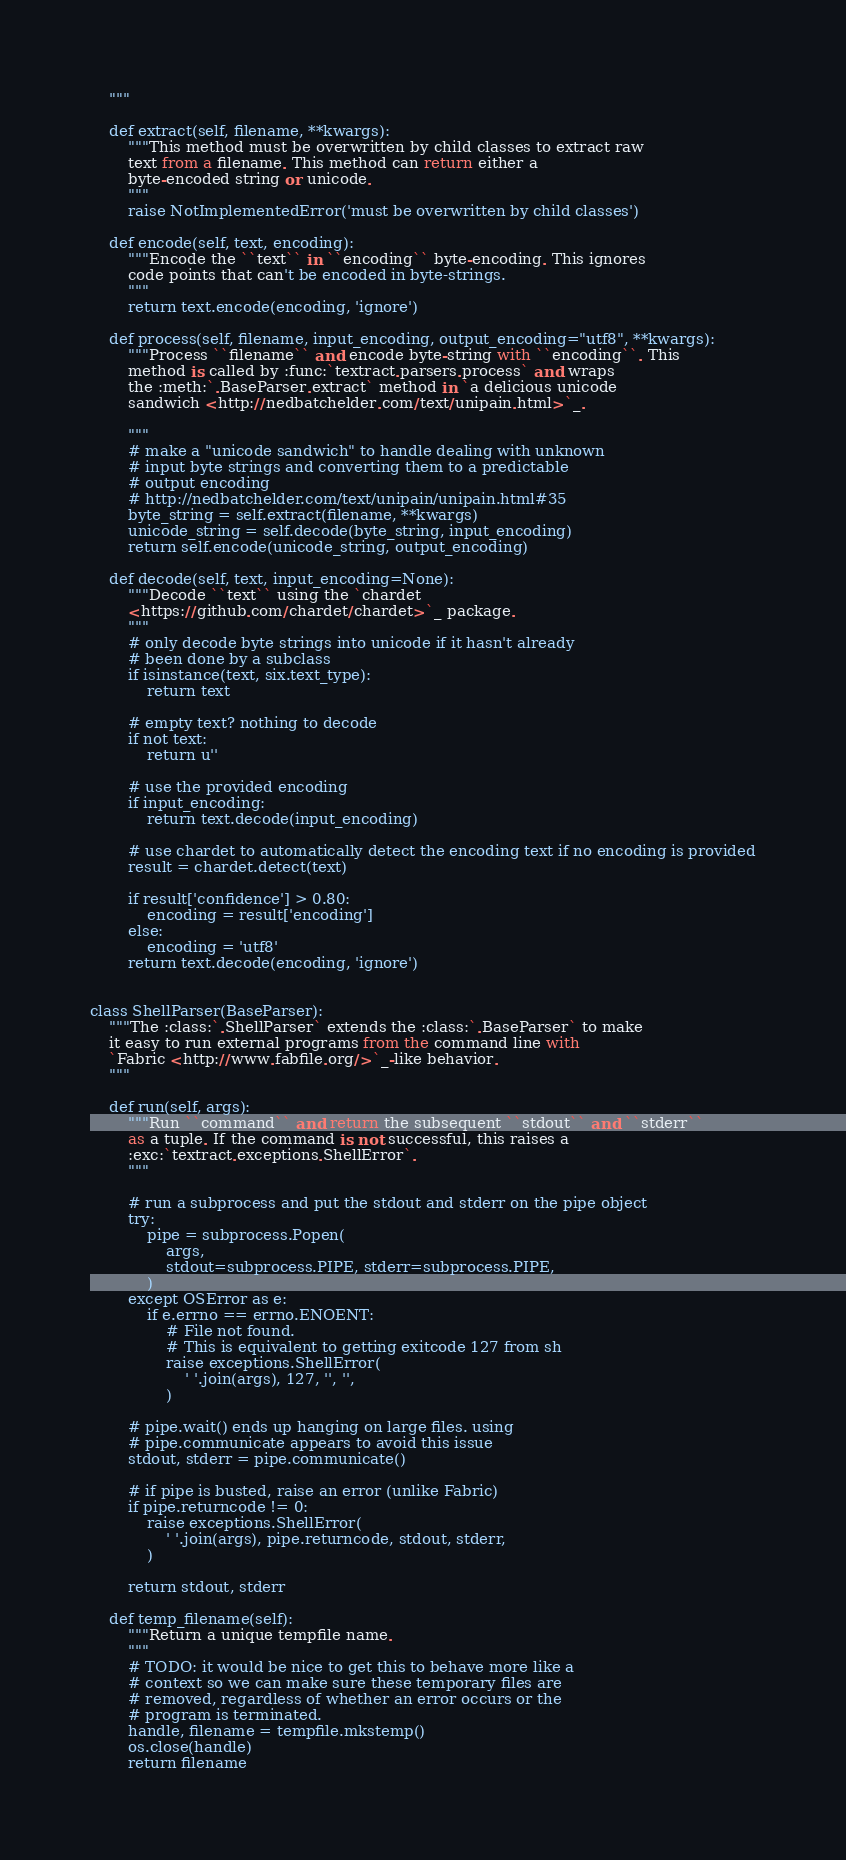Convert code to text. <code><loc_0><loc_0><loc_500><loc_500><_Python_>    """

    def extract(self, filename, **kwargs):
        """This method must be overwritten by child classes to extract raw
        text from a filename. This method can return either a
        byte-encoded string or unicode.
        """
        raise NotImplementedError('must be overwritten by child classes')

    def encode(self, text, encoding):
        """Encode the ``text`` in ``encoding`` byte-encoding. This ignores
        code points that can't be encoded in byte-strings.
        """
        return text.encode(encoding, 'ignore')

    def process(self, filename, input_encoding, output_encoding="utf8", **kwargs):
        """Process ``filename`` and encode byte-string with ``encoding``. This
        method is called by :func:`textract.parsers.process` and wraps
        the :meth:`.BaseParser.extract` method in `a delicious unicode
        sandwich <http://nedbatchelder.com/text/unipain.html>`_.

        """
        # make a "unicode sandwich" to handle dealing with unknown
        # input byte strings and converting them to a predictable
        # output encoding
        # http://nedbatchelder.com/text/unipain/unipain.html#35
        byte_string = self.extract(filename, **kwargs)
        unicode_string = self.decode(byte_string, input_encoding)
        return self.encode(unicode_string, output_encoding)

    def decode(self, text, input_encoding=None):
        """Decode ``text`` using the `chardet
        <https://github.com/chardet/chardet>`_ package.
        """
        # only decode byte strings into unicode if it hasn't already
        # been done by a subclass
        if isinstance(text, six.text_type):
            return text

        # empty text? nothing to decode
        if not text:
            return u''

        # use the provided encoding
        if input_encoding:
            return text.decode(input_encoding)

        # use chardet to automatically detect the encoding text if no encoding is provided
        result = chardet.detect(text)

        if result['confidence'] > 0.80:
            encoding = result['encoding']
        else:
            encoding = 'utf8'
        return text.decode(encoding, 'ignore')


class ShellParser(BaseParser):
    """The :class:`.ShellParser` extends the :class:`.BaseParser` to make
    it easy to run external programs from the command line with
    `Fabric <http://www.fabfile.org/>`_-like behavior.
    """

    def run(self, args):
        """Run ``command`` and return the subsequent ``stdout`` and ``stderr``
        as a tuple. If the command is not successful, this raises a
        :exc:`textract.exceptions.ShellError`.
        """

        # run a subprocess and put the stdout and stderr on the pipe object
        try:
            pipe = subprocess.Popen(
                args,
                stdout=subprocess.PIPE, stderr=subprocess.PIPE,
            )
        except OSError as e:
            if e.errno == errno.ENOENT:
                # File not found.
                # This is equivalent to getting exitcode 127 from sh
                raise exceptions.ShellError(
                    ' '.join(args), 127, '', '',
                )

        # pipe.wait() ends up hanging on large files. using
        # pipe.communicate appears to avoid this issue
        stdout, stderr = pipe.communicate()

        # if pipe is busted, raise an error (unlike Fabric)
        if pipe.returncode != 0:
            raise exceptions.ShellError(
                ' '.join(args), pipe.returncode, stdout, stderr,
            )

        return stdout, stderr

    def temp_filename(self):
        """Return a unique tempfile name.
        """
        # TODO: it would be nice to get this to behave more like a
        # context so we can make sure these temporary files are
        # removed, regardless of whether an error occurs or the
        # program is terminated.
        handle, filename = tempfile.mkstemp()
        os.close(handle)
        return filename
</code> 